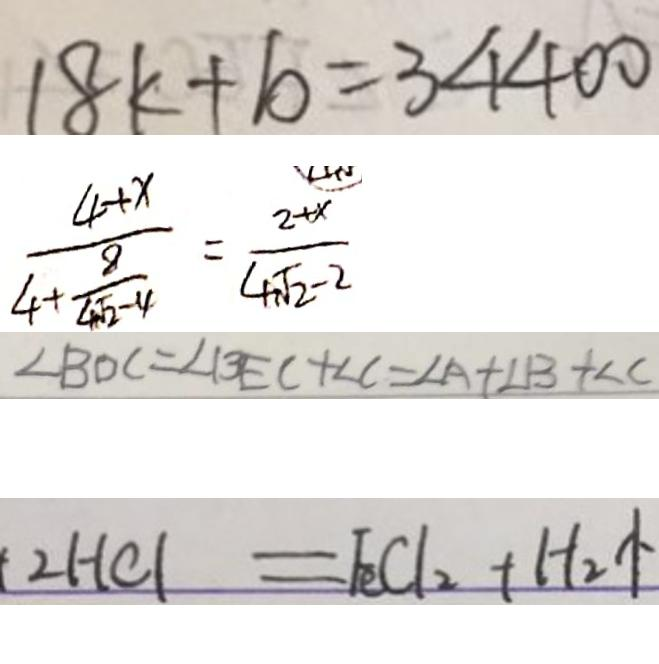<formula> <loc_0><loc_0><loc_500><loc_500>1 8 k + 1 0 = 3 4 4 0 0 
 \frac { 4 + x } { 4 + \frac { 8 } { 4 \sqrt { 2 } - 4 } } = \frac { 2 + x } { 4 \sqrt { 2 } - 2 } 
 \angle B D C = \angle B E C + \angle C = \angle A + \angle B + \angle C 
 2 H C l = F e C l _ { 2 } + H _ { 2 } \uparrow</formula> 